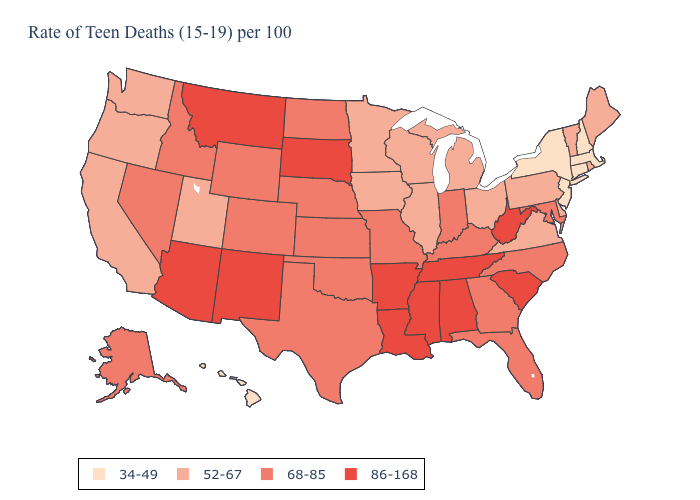What is the lowest value in states that border Massachusetts?
Be succinct. 34-49. What is the lowest value in the USA?
Quick response, please. 34-49. Among the states that border New Mexico , does Arizona have the highest value?
Keep it brief. Yes. Does Minnesota have a lower value than Oklahoma?
Short answer required. Yes. Does Delaware have the highest value in the South?
Be succinct. No. What is the value of Delaware?
Be succinct. 52-67. What is the value of Wisconsin?
Short answer required. 52-67. What is the value of Washington?
Keep it brief. 52-67. Does New Jersey have the highest value in the Northeast?
Write a very short answer. No. What is the value of North Dakota?
Keep it brief. 68-85. What is the value of New York?
Keep it brief. 34-49. Does North Dakota have the lowest value in the MidWest?
Be succinct. No. What is the value of Montana?
Write a very short answer. 86-168. What is the value of Nebraska?
Answer briefly. 68-85. Name the states that have a value in the range 86-168?
Answer briefly. Alabama, Arizona, Arkansas, Louisiana, Mississippi, Montana, New Mexico, South Carolina, South Dakota, Tennessee, West Virginia. 